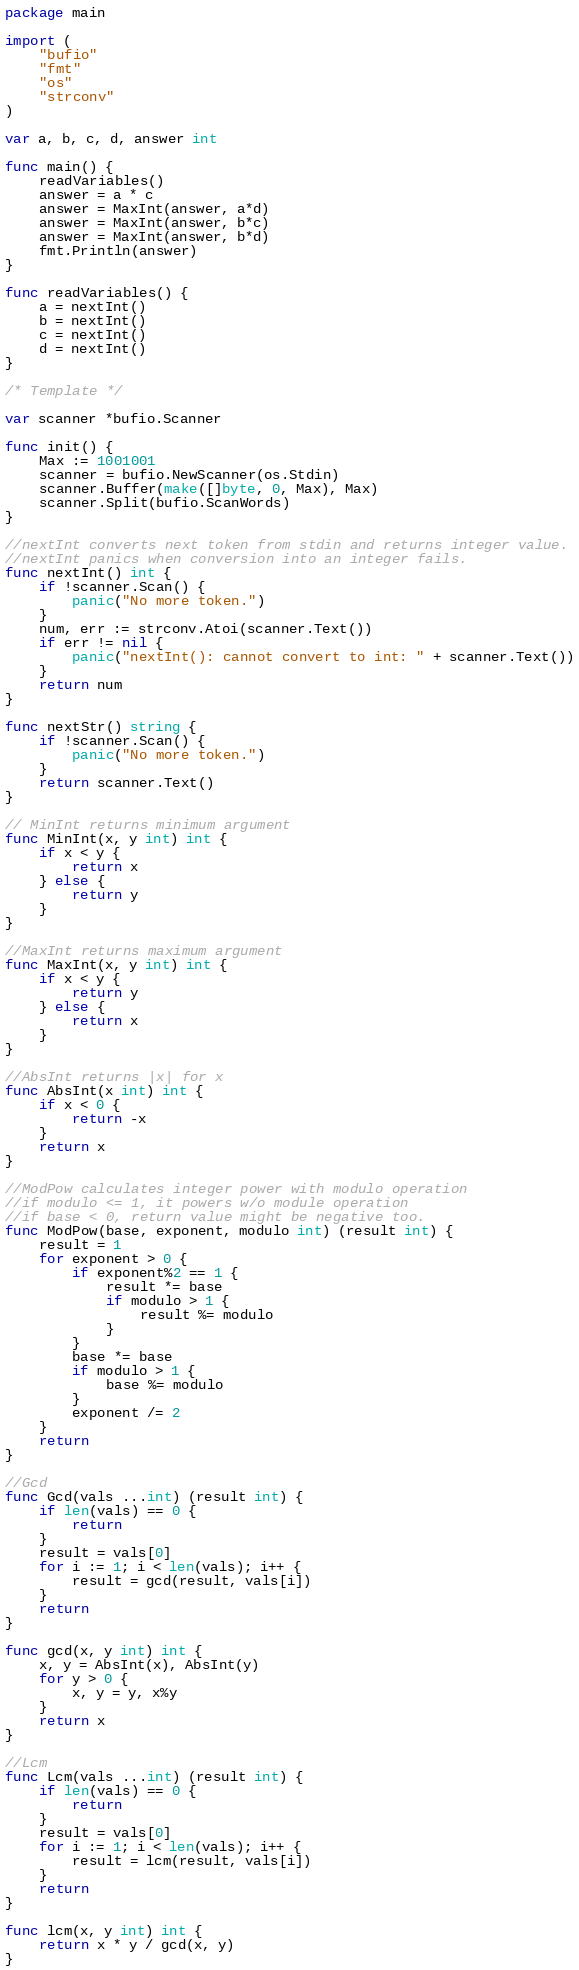<code> <loc_0><loc_0><loc_500><loc_500><_Go_>package main

import (
	"bufio"
	"fmt"
	"os"
	"strconv"
)

var a, b, c, d, answer int

func main() {
	readVariables()
	answer = a * c
	answer = MaxInt(answer, a*d)
	answer = MaxInt(answer, b*c)
	answer = MaxInt(answer, b*d)
	fmt.Println(answer)
}

func readVariables() {
	a = nextInt()
	b = nextInt()
	c = nextInt()
	d = nextInt()
}

/* Template */

var scanner *bufio.Scanner

func init() {
	Max := 1001001
	scanner = bufio.NewScanner(os.Stdin)
	scanner.Buffer(make([]byte, 0, Max), Max)
	scanner.Split(bufio.ScanWords)
}

//nextInt converts next token from stdin and returns integer value.
//nextInt panics when conversion into an integer fails.
func nextInt() int {
	if !scanner.Scan() {
		panic("No more token.")
	}
	num, err := strconv.Atoi(scanner.Text())
	if err != nil {
		panic("nextInt(): cannot convert to int: " + scanner.Text())
	}
	return num
}

func nextStr() string {
	if !scanner.Scan() {
		panic("No more token.")
	}
	return scanner.Text()
}

// MinInt returns minimum argument
func MinInt(x, y int) int {
	if x < y {
		return x
	} else {
		return y
	}
}

//MaxInt returns maximum argument
func MaxInt(x, y int) int {
	if x < y {
		return y
	} else {
		return x
	}
}

//AbsInt returns |x| for x
func AbsInt(x int) int {
	if x < 0 {
		return -x
	}
	return x
}

//ModPow calculates integer power with modulo operation
//if modulo <= 1, it powers w/o module operation
//if base < 0, return value might be negative too.
func ModPow(base, exponent, modulo int) (result int) {
	result = 1
	for exponent > 0 {
		if exponent%2 == 1 {
			result *= base
			if modulo > 1 {
				result %= modulo
			}
		}
		base *= base
		if modulo > 1 {
			base %= modulo
		}
		exponent /= 2
	}
	return
}

//Gcd
func Gcd(vals ...int) (result int) {
	if len(vals) == 0 {
		return
	}
	result = vals[0]
	for i := 1; i < len(vals); i++ {
		result = gcd(result, vals[i])
	}
	return
}

func gcd(x, y int) int {
	x, y = AbsInt(x), AbsInt(y)
	for y > 0 {
		x, y = y, x%y
	}
	return x
}

//Lcm
func Lcm(vals ...int) (result int) {
	if len(vals) == 0 {
		return
	}
	result = vals[0]
	for i := 1; i < len(vals); i++ {
		result = lcm(result, vals[i])
	}
	return
}

func lcm(x, y int) int {
	return x * y / gcd(x, y)
}
</code> 